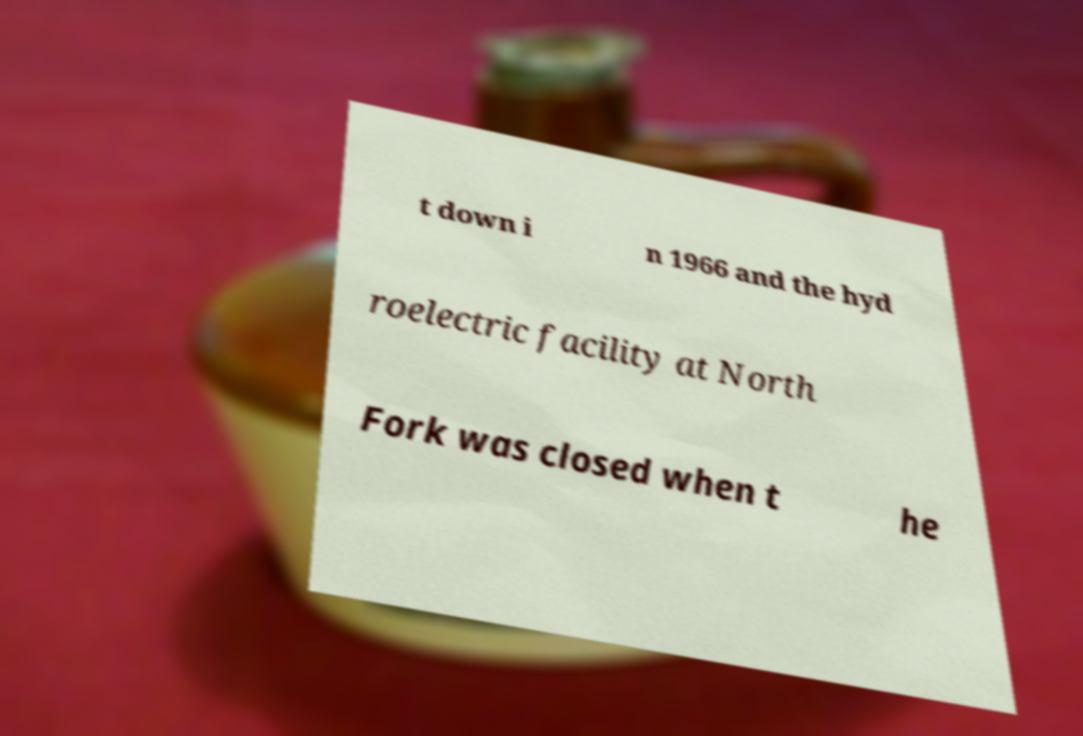Please read and relay the text visible in this image. What does it say? t down i n 1966 and the hyd roelectric facility at North Fork was closed when t he 